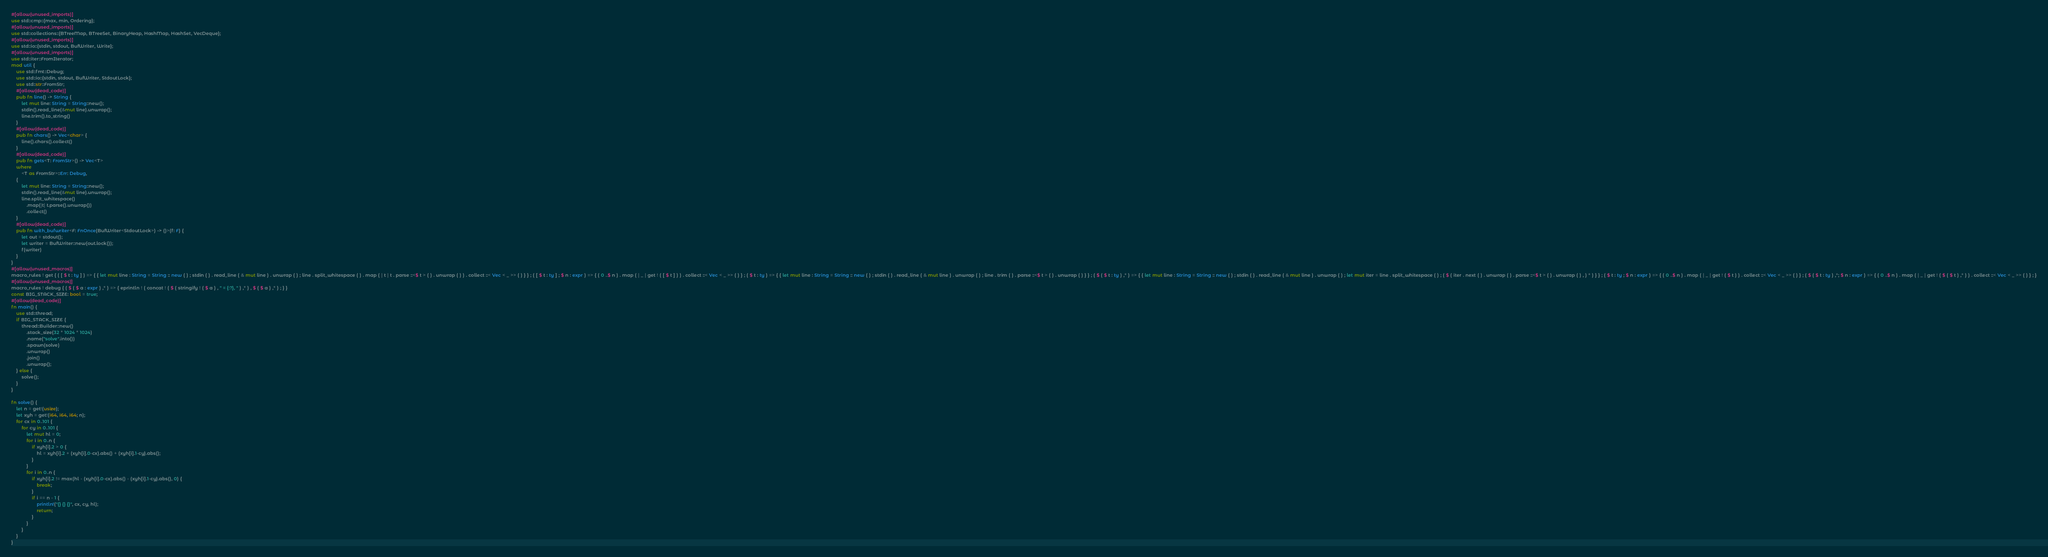Convert code to text. <code><loc_0><loc_0><loc_500><loc_500><_Rust_>#[allow(unused_imports)]
use std::cmp::{max, min, Ordering};
#[allow(unused_imports)]
use std::collections::{BTreeMap, BTreeSet, BinaryHeap, HashMap, HashSet, VecDeque};
#[allow(unused_imports)]
use std::io::{stdin, stdout, BufWriter, Write};
#[allow(unused_imports)]
use std::iter::FromIterator;
mod util {
    use std::fmt::Debug;
    use std::io::{stdin, stdout, BufWriter, StdoutLock};
    use std::str::FromStr;
    #[allow(dead_code)]
    pub fn line() -> String {
        let mut line: String = String::new();
        stdin().read_line(&mut line).unwrap();
        line.trim().to_string()
    }
    #[allow(dead_code)]
    pub fn chars() -> Vec<char> {
        line().chars().collect()
    }
    #[allow(dead_code)]
    pub fn gets<T: FromStr>() -> Vec<T>
    where
        <T as FromStr>::Err: Debug,
    {
        let mut line: String = String::new();
        stdin().read_line(&mut line).unwrap();
        line.split_whitespace()
            .map(|t| t.parse().unwrap())
            .collect()
    }
    #[allow(dead_code)]
    pub fn with_bufwriter<F: FnOnce(BufWriter<StdoutLock>) -> ()>(f: F) {
        let out = stdout();
        let writer = BufWriter::new(out.lock());
        f(writer)
    }
}
#[allow(unused_macros)]
macro_rules ! get { ( [ $ t : ty ] ) => { { let mut line : String = String :: new ( ) ; stdin ( ) . read_line ( & mut line ) . unwrap ( ) ; line . split_whitespace ( ) . map ( | t | t . parse ::<$ t > ( ) . unwrap ( ) ) . collect ::< Vec < _ >> ( ) } } ; ( [ $ t : ty ] ; $ n : expr ) => { ( 0 ..$ n ) . map ( | _ | get ! ( [ $ t ] ) ) . collect ::< Vec < _ >> ( ) } ; ( $ t : ty ) => { { let mut line : String = String :: new ( ) ; stdin ( ) . read_line ( & mut line ) . unwrap ( ) ; line . trim ( ) . parse ::<$ t > ( ) . unwrap ( ) } } ; ( $ ( $ t : ty ) ,* ) => { { let mut line : String = String :: new ( ) ; stdin ( ) . read_line ( & mut line ) . unwrap ( ) ; let mut iter = line . split_whitespace ( ) ; ( $ ( iter . next ( ) . unwrap ( ) . parse ::<$ t > ( ) . unwrap ( ) , ) * ) } } ; ( $ t : ty ; $ n : expr ) => { ( 0 ..$ n ) . map ( | _ | get ! ( $ t ) ) . collect ::< Vec < _ >> ( ) } ; ( $ ( $ t : ty ) ,*; $ n : expr ) => { ( 0 ..$ n ) . map ( | _ | get ! ( $ ( $ t ) ,* ) ) . collect ::< Vec < _ >> ( ) } ; }
#[allow(unused_macros)]
macro_rules ! debug { ( $ ( $ a : expr ) ,* ) => { eprintln ! ( concat ! ( $ ( stringify ! ( $ a ) , " = {:?}, " ) ,* ) , $ ( $ a ) ,* ) ; } }
const BIG_STACK_SIZE: bool = true;
#[allow(dead_code)]
fn main() {
    use std::thread;
    if BIG_STACK_SIZE {
        thread::Builder::new()
            .stack_size(32 * 1024 * 1024)
            .name("solve".into())
            .spawn(solve)
            .unwrap()
            .join()
            .unwrap();
    } else {
        solve();
    }
}

fn solve() {
    let n = get!(usize);
    let xyh = get!(i64, i64, i64; n);
    for cx in 0..101 {
        for cy in 0..101 {
            let mut hl = 0;
            for i in 0..n {
                if xyh[i].2 > 0 {
                    hl = xyh[i].2 + (xyh[i].0-cx).abs() + (xyh[i].1-cy).abs();
                }
            }
            for i in 0..n {
                if xyh[i].2 != max(hl - (xyh[i].0-cx).abs() - (xyh[i].1-cy).abs(), 0) {
                    break;
                }
                if i == n - 1 {
                    println!("{} {} {}", cx, cy, hl);
                    return;
                }
            }
        }
    }
}
</code> 